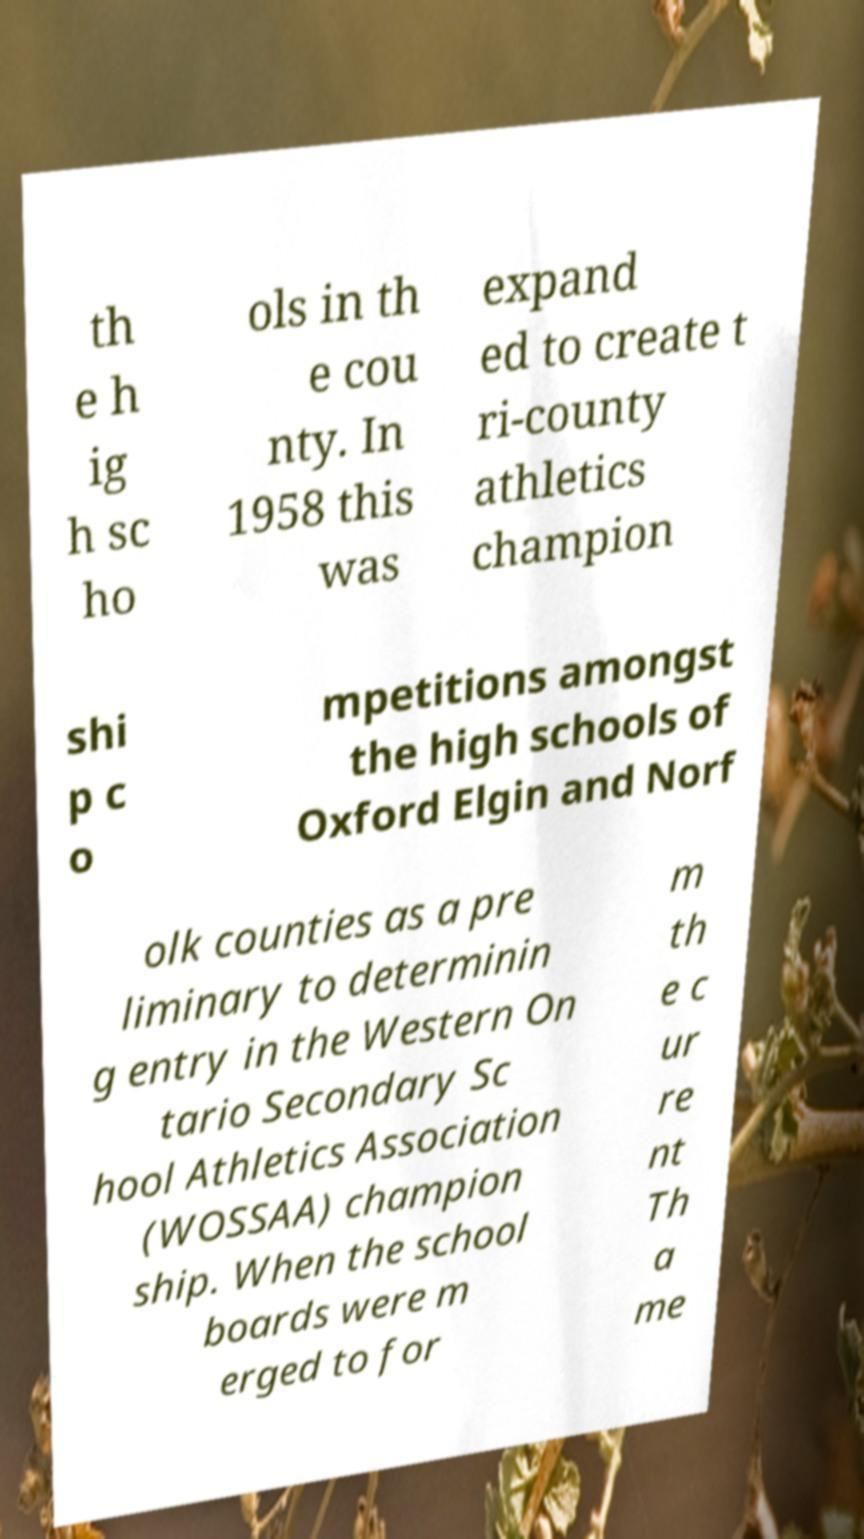Can you accurately transcribe the text from the provided image for me? th e h ig h sc ho ols in th e cou nty. In 1958 this was expand ed to create t ri-county athletics champion shi p c o mpetitions amongst the high schools of Oxford Elgin and Norf olk counties as a pre liminary to determinin g entry in the Western On tario Secondary Sc hool Athletics Association (WOSSAA) champion ship. When the school boards were m erged to for m th e c ur re nt Th a me 